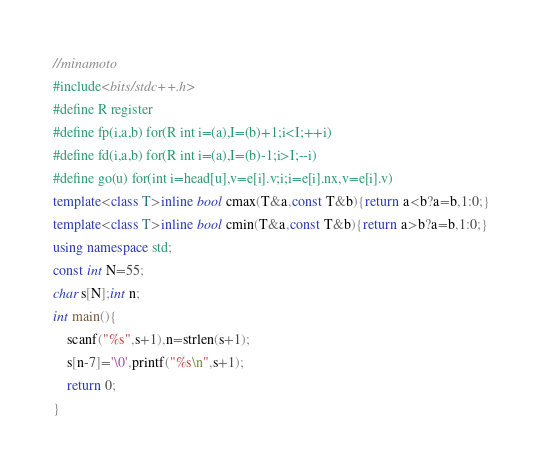Convert code to text. <code><loc_0><loc_0><loc_500><loc_500><_C++_>//minamoto
#include<bits/stdc++.h>
#define R register
#define fp(i,a,b) for(R int i=(a),I=(b)+1;i<I;++i)
#define fd(i,a,b) for(R int i=(a),I=(b)-1;i>I;--i)
#define go(u) for(int i=head[u],v=e[i].v;i;i=e[i].nx,v=e[i].v)
template<class T>inline bool cmax(T&a,const T&b){return a<b?a=b,1:0;}
template<class T>inline bool cmin(T&a,const T&b){return a>b?a=b,1:0;}
using namespace std;
const int N=55;
char s[N];int n;
int main(){
	scanf("%s",s+1),n=strlen(s+1);
	s[n-7]='\0',printf("%s\n",s+1);
	return 0;
}</code> 